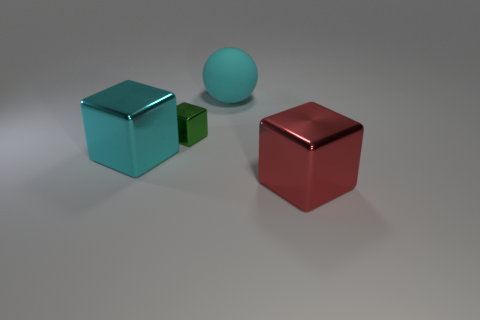Is there anything else that has the same material as the large cyan sphere?
Offer a terse response. No. Is there a green object made of the same material as the tiny block?
Your answer should be compact. No. Is the number of small green metal objects that are in front of the green object less than the number of tiny yellow matte cylinders?
Give a very brief answer. No. There is a big cube left of the block right of the matte thing; what is it made of?
Offer a very short reply. Metal. The thing that is on the right side of the tiny green cube and in front of the green thing has what shape?
Ensure brevity in your answer.  Cube. What number of other objects are the same color as the big matte sphere?
Offer a terse response. 1. What number of things are either metallic objects in front of the tiny green metal block or small green rubber blocks?
Your response must be concise. 2. There is a big matte thing; does it have the same color as the big block that is on the left side of the big red object?
Offer a very short reply. Yes. Is there anything else that has the same size as the green shiny object?
Your response must be concise. No. What is the size of the cube that is behind the big shiny object to the left of the big sphere?
Give a very brief answer. Small. 